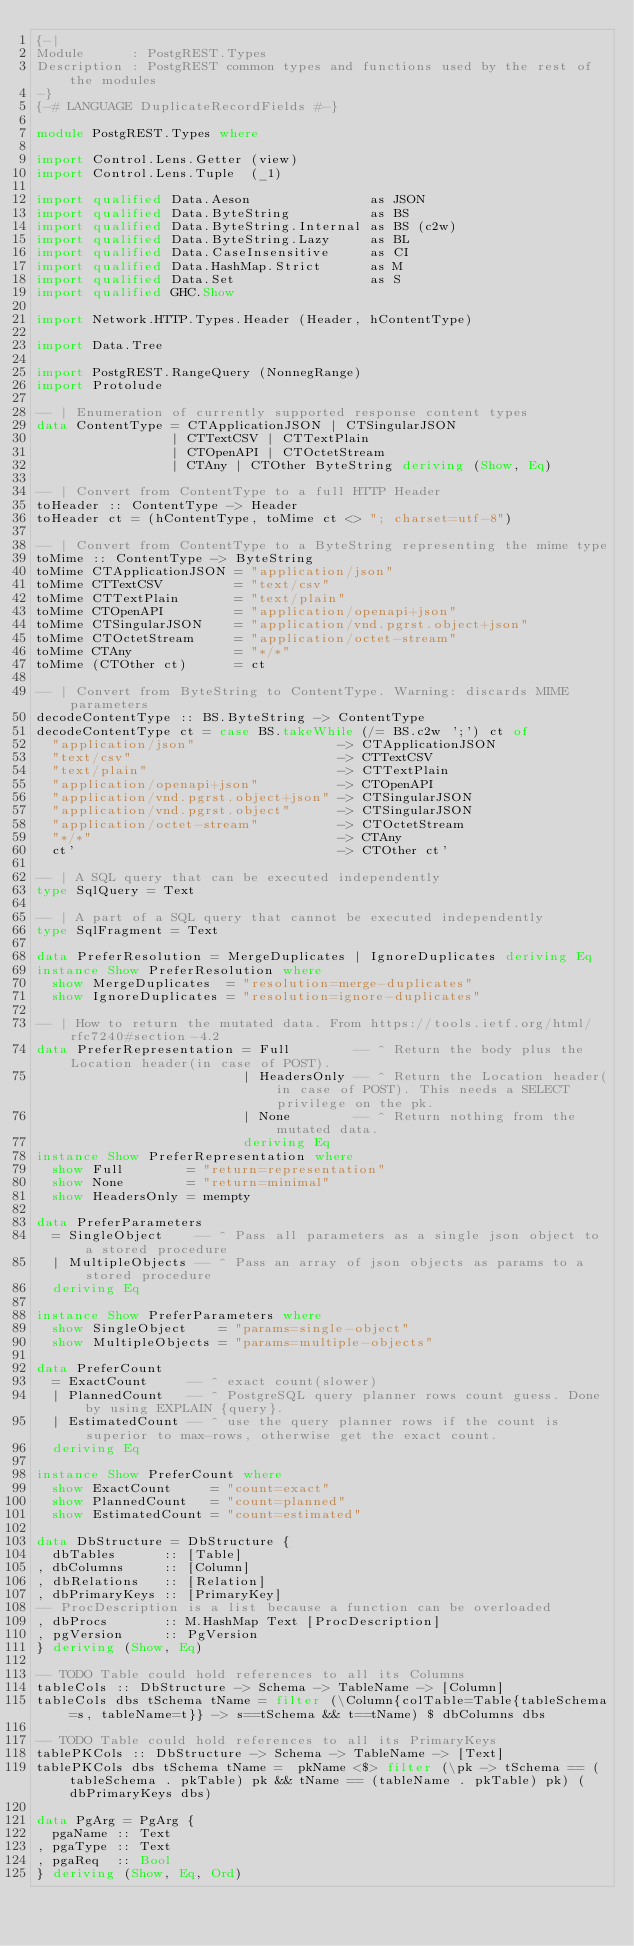Convert code to text. <code><loc_0><loc_0><loc_500><loc_500><_Haskell_>{-|
Module      : PostgREST.Types
Description : PostgREST common types and functions used by the rest of the modules
-}
{-# LANGUAGE DuplicateRecordFields #-}

module PostgREST.Types where

import Control.Lens.Getter (view)
import Control.Lens.Tuple  (_1)

import qualified Data.Aeson               as JSON
import qualified Data.ByteString          as BS
import qualified Data.ByteString.Internal as BS (c2w)
import qualified Data.ByteString.Lazy     as BL
import qualified Data.CaseInsensitive     as CI
import qualified Data.HashMap.Strict      as M
import qualified Data.Set                 as S
import qualified GHC.Show

import Network.HTTP.Types.Header (Header, hContentType)

import Data.Tree

import PostgREST.RangeQuery (NonnegRange)
import Protolude

-- | Enumeration of currently supported response content types
data ContentType = CTApplicationJSON | CTSingularJSON
                 | CTTextCSV | CTTextPlain
                 | CTOpenAPI | CTOctetStream
                 | CTAny | CTOther ByteString deriving (Show, Eq)

-- | Convert from ContentType to a full HTTP Header
toHeader :: ContentType -> Header
toHeader ct = (hContentType, toMime ct <> "; charset=utf-8")

-- | Convert from ContentType to a ByteString representing the mime type
toMime :: ContentType -> ByteString
toMime CTApplicationJSON = "application/json"
toMime CTTextCSV         = "text/csv"
toMime CTTextPlain       = "text/plain"
toMime CTOpenAPI         = "application/openapi+json"
toMime CTSingularJSON    = "application/vnd.pgrst.object+json"
toMime CTOctetStream     = "application/octet-stream"
toMime CTAny             = "*/*"
toMime (CTOther ct)      = ct

-- | Convert from ByteString to ContentType. Warning: discards MIME parameters
decodeContentType :: BS.ByteString -> ContentType
decodeContentType ct = case BS.takeWhile (/= BS.c2w ';') ct of
  "application/json"                  -> CTApplicationJSON
  "text/csv"                          -> CTTextCSV
  "text/plain"                        -> CTTextPlain
  "application/openapi+json"          -> CTOpenAPI
  "application/vnd.pgrst.object+json" -> CTSingularJSON
  "application/vnd.pgrst.object"      -> CTSingularJSON
  "application/octet-stream"          -> CTOctetStream
  "*/*"                               -> CTAny
  ct'                                 -> CTOther ct'

-- | A SQL query that can be executed independently
type SqlQuery = Text

-- | A part of a SQL query that cannot be executed independently
type SqlFragment = Text

data PreferResolution = MergeDuplicates | IgnoreDuplicates deriving Eq
instance Show PreferResolution where
  show MergeDuplicates  = "resolution=merge-duplicates"
  show IgnoreDuplicates = "resolution=ignore-duplicates"

-- | How to return the mutated data. From https://tools.ietf.org/html/rfc7240#section-4.2
data PreferRepresentation = Full        -- ^ Return the body plus the Location header(in case of POST).
                          | HeadersOnly -- ^ Return the Location header(in case of POST). This needs a SELECT privilege on the pk.
                          | None        -- ^ Return nothing from the mutated data.
                          deriving Eq
instance Show PreferRepresentation where
  show Full        = "return=representation"
  show None        = "return=minimal"
  show HeadersOnly = mempty

data PreferParameters
  = SingleObject    -- ^ Pass all parameters as a single json object to a stored procedure
  | MultipleObjects -- ^ Pass an array of json objects as params to a stored procedure
  deriving Eq

instance Show PreferParameters where
  show SingleObject    = "params=single-object"
  show MultipleObjects = "params=multiple-objects"

data PreferCount
  = ExactCount     -- ^ exact count(slower)
  | PlannedCount   -- ^ PostgreSQL query planner rows count guess. Done by using EXPLAIN {query}.
  | EstimatedCount -- ^ use the query planner rows if the count is superior to max-rows, otherwise get the exact count.
  deriving Eq

instance Show PreferCount where
  show ExactCount     = "count=exact"
  show PlannedCount   = "count=planned"
  show EstimatedCount = "count=estimated"

data DbStructure = DbStructure {
  dbTables      :: [Table]
, dbColumns     :: [Column]
, dbRelations   :: [Relation]
, dbPrimaryKeys :: [PrimaryKey]
-- ProcDescription is a list because a function can be overloaded
, dbProcs       :: M.HashMap Text [ProcDescription]
, pgVersion     :: PgVersion
} deriving (Show, Eq)

-- TODO Table could hold references to all its Columns
tableCols :: DbStructure -> Schema -> TableName -> [Column]
tableCols dbs tSchema tName = filter (\Column{colTable=Table{tableSchema=s, tableName=t}} -> s==tSchema && t==tName) $ dbColumns dbs

-- TODO Table could hold references to all its PrimaryKeys
tablePKCols :: DbStructure -> Schema -> TableName -> [Text]
tablePKCols dbs tSchema tName =  pkName <$> filter (\pk -> tSchema == (tableSchema . pkTable) pk && tName == (tableName . pkTable) pk) (dbPrimaryKeys dbs)

data PgArg = PgArg {
  pgaName :: Text
, pgaType :: Text
, pgaReq  :: Bool
} deriving (Show, Eq, Ord)
</code> 